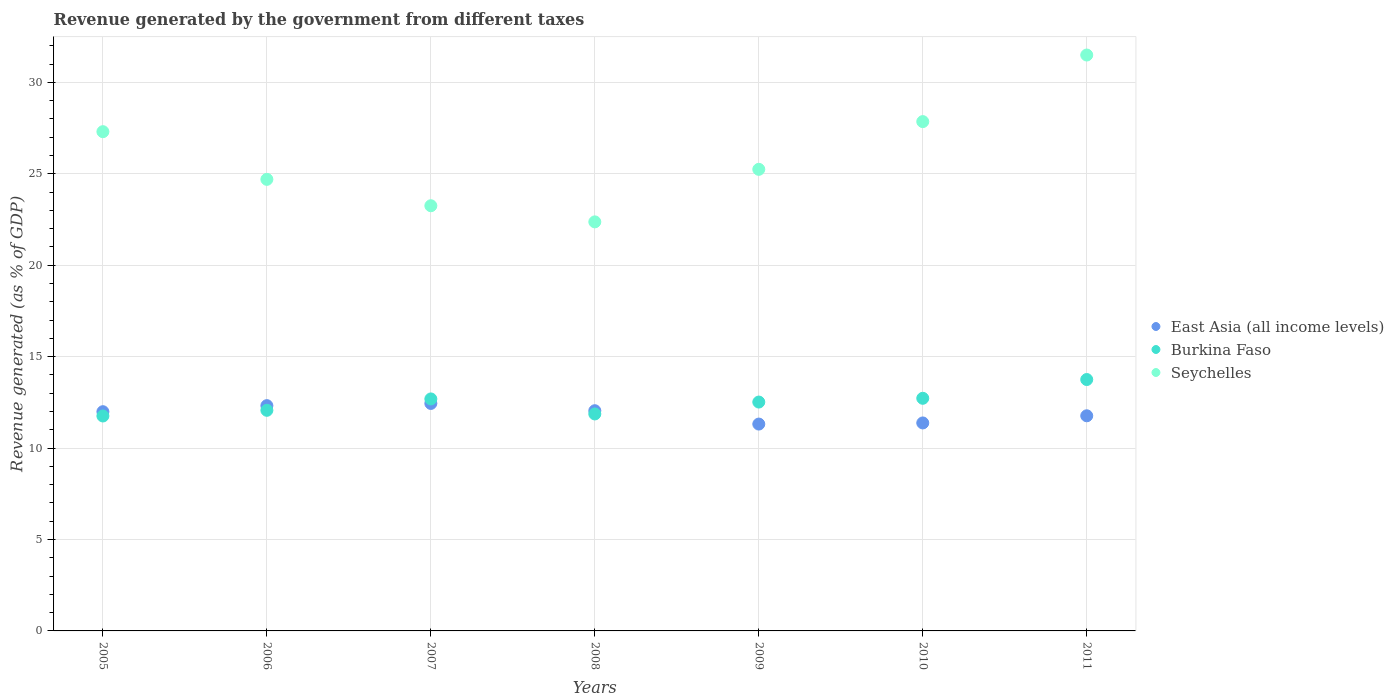Is the number of dotlines equal to the number of legend labels?
Give a very brief answer. Yes. What is the revenue generated by the government in Seychelles in 2006?
Keep it short and to the point. 24.69. Across all years, what is the maximum revenue generated by the government in East Asia (all income levels)?
Provide a succinct answer. 12.44. Across all years, what is the minimum revenue generated by the government in Burkina Faso?
Your answer should be very brief. 11.75. What is the total revenue generated by the government in Seychelles in the graph?
Your response must be concise. 182.19. What is the difference between the revenue generated by the government in Seychelles in 2005 and that in 2011?
Keep it short and to the point. -4.19. What is the difference between the revenue generated by the government in East Asia (all income levels) in 2007 and the revenue generated by the government in Burkina Faso in 2008?
Provide a short and direct response. 0.57. What is the average revenue generated by the government in Burkina Faso per year?
Make the answer very short. 12.48. In the year 2009, what is the difference between the revenue generated by the government in Burkina Faso and revenue generated by the government in East Asia (all income levels)?
Offer a very short reply. 1.2. What is the ratio of the revenue generated by the government in Burkina Faso in 2006 to that in 2009?
Ensure brevity in your answer.  0.96. Is the revenue generated by the government in Seychelles in 2007 less than that in 2008?
Your answer should be very brief. No. Is the difference between the revenue generated by the government in Burkina Faso in 2010 and 2011 greater than the difference between the revenue generated by the government in East Asia (all income levels) in 2010 and 2011?
Make the answer very short. No. What is the difference between the highest and the second highest revenue generated by the government in Burkina Faso?
Give a very brief answer. 1.03. What is the difference between the highest and the lowest revenue generated by the government in East Asia (all income levels)?
Offer a very short reply. 1.13. Is the sum of the revenue generated by the government in East Asia (all income levels) in 2010 and 2011 greater than the maximum revenue generated by the government in Burkina Faso across all years?
Provide a succinct answer. Yes. How many dotlines are there?
Give a very brief answer. 3. What is the difference between two consecutive major ticks on the Y-axis?
Give a very brief answer. 5. How are the legend labels stacked?
Ensure brevity in your answer.  Vertical. What is the title of the graph?
Provide a succinct answer. Revenue generated by the government from different taxes. What is the label or title of the X-axis?
Make the answer very short. Years. What is the label or title of the Y-axis?
Your answer should be compact. Revenue generated (as % of GDP). What is the Revenue generated (as % of GDP) in East Asia (all income levels) in 2005?
Ensure brevity in your answer.  11.99. What is the Revenue generated (as % of GDP) in Burkina Faso in 2005?
Keep it short and to the point. 11.75. What is the Revenue generated (as % of GDP) in Seychelles in 2005?
Keep it short and to the point. 27.3. What is the Revenue generated (as % of GDP) of East Asia (all income levels) in 2006?
Make the answer very short. 12.32. What is the Revenue generated (as % of GDP) of Burkina Faso in 2006?
Ensure brevity in your answer.  12.06. What is the Revenue generated (as % of GDP) in Seychelles in 2006?
Make the answer very short. 24.69. What is the Revenue generated (as % of GDP) of East Asia (all income levels) in 2007?
Give a very brief answer. 12.44. What is the Revenue generated (as % of GDP) in Burkina Faso in 2007?
Keep it short and to the point. 12.69. What is the Revenue generated (as % of GDP) in Seychelles in 2007?
Offer a very short reply. 23.25. What is the Revenue generated (as % of GDP) of East Asia (all income levels) in 2008?
Give a very brief answer. 12.04. What is the Revenue generated (as % of GDP) in Burkina Faso in 2008?
Offer a very short reply. 11.86. What is the Revenue generated (as % of GDP) of Seychelles in 2008?
Offer a terse response. 22.37. What is the Revenue generated (as % of GDP) of East Asia (all income levels) in 2009?
Ensure brevity in your answer.  11.31. What is the Revenue generated (as % of GDP) in Burkina Faso in 2009?
Offer a terse response. 12.52. What is the Revenue generated (as % of GDP) of Seychelles in 2009?
Offer a very short reply. 25.24. What is the Revenue generated (as % of GDP) in East Asia (all income levels) in 2010?
Your response must be concise. 11.37. What is the Revenue generated (as % of GDP) of Burkina Faso in 2010?
Ensure brevity in your answer.  12.72. What is the Revenue generated (as % of GDP) in Seychelles in 2010?
Your answer should be compact. 27.85. What is the Revenue generated (as % of GDP) in East Asia (all income levels) in 2011?
Offer a terse response. 11.76. What is the Revenue generated (as % of GDP) in Burkina Faso in 2011?
Give a very brief answer. 13.75. What is the Revenue generated (as % of GDP) of Seychelles in 2011?
Your answer should be compact. 31.49. Across all years, what is the maximum Revenue generated (as % of GDP) of East Asia (all income levels)?
Offer a terse response. 12.44. Across all years, what is the maximum Revenue generated (as % of GDP) of Burkina Faso?
Provide a succinct answer. 13.75. Across all years, what is the maximum Revenue generated (as % of GDP) in Seychelles?
Ensure brevity in your answer.  31.49. Across all years, what is the minimum Revenue generated (as % of GDP) of East Asia (all income levels)?
Provide a short and direct response. 11.31. Across all years, what is the minimum Revenue generated (as % of GDP) in Burkina Faso?
Your response must be concise. 11.75. Across all years, what is the minimum Revenue generated (as % of GDP) in Seychelles?
Provide a short and direct response. 22.37. What is the total Revenue generated (as % of GDP) in East Asia (all income levels) in the graph?
Ensure brevity in your answer.  83.24. What is the total Revenue generated (as % of GDP) in Burkina Faso in the graph?
Make the answer very short. 87.35. What is the total Revenue generated (as % of GDP) in Seychelles in the graph?
Offer a very short reply. 182.19. What is the difference between the Revenue generated (as % of GDP) in East Asia (all income levels) in 2005 and that in 2006?
Provide a short and direct response. -0.33. What is the difference between the Revenue generated (as % of GDP) in Burkina Faso in 2005 and that in 2006?
Offer a very short reply. -0.31. What is the difference between the Revenue generated (as % of GDP) in Seychelles in 2005 and that in 2006?
Ensure brevity in your answer.  2.61. What is the difference between the Revenue generated (as % of GDP) of East Asia (all income levels) in 2005 and that in 2007?
Make the answer very short. -0.45. What is the difference between the Revenue generated (as % of GDP) in Burkina Faso in 2005 and that in 2007?
Keep it short and to the point. -0.93. What is the difference between the Revenue generated (as % of GDP) in Seychelles in 2005 and that in 2007?
Your answer should be compact. 4.05. What is the difference between the Revenue generated (as % of GDP) of East Asia (all income levels) in 2005 and that in 2008?
Your answer should be compact. -0.05. What is the difference between the Revenue generated (as % of GDP) of Burkina Faso in 2005 and that in 2008?
Your answer should be compact. -0.11. What is the difference between the Revenue generated (as % of GDP) of Seychelles in 2005 and that in 2008?
Your response must be concise. 4.93. What is the difference between the Revenue generated (as % of GDP) in East Asia (all income levels) in 2005 and that in 2009?
Your answer should be compact. 0.68. What is the difference between the Revenue generated (as % of GDP) in Burkina Faso in 2005 and that in 2009?
Give a very brief answer. -0.76. What is the difference between the Revenue generated (as % of GDP) of Seychelles in 2005 and that in 2009?
Keep it short and to the point. 2.06. What is the difference between the Revenue generated (as % of GDP) of East Asia (all income levels) in 2005 and that in 2010?
Offer a very short reply. 0.61. What is the difference between the Revenue generated (as % of GDP) in Burkina Faso in 2005 and that in 2010?
Provide a short and direct response. -0.97. What is the difference between the Revenue generated (as % of GDP) of Seychelles in 2005 and that in 2010?
Keep it short and to the point. -0.55. What is the difference between the Revenue generated (as % of GDP) of East Asia (all income levels) in 2005 and that in 2011?
Your answer should be compact. 0.22. What is the difference between the Revenue generated (as % of GDP) in Burkina Faso in 2005 and that in 2011?
Make the answer very short. -1.99. What is the difference between the Revenue generated (as % of GDP) in Seychelles in 2005 and that in 2011?
Your response must be concise. -4.19. What is the difference between the Revenue generated (as % of GDP) of East Asia (all income levels) in 2006 and that in 2007?
Your response must be concise. -0.12. What is the difference between the Revenue generated (as % of GDP) in Burkina Faso in 2006 and that in 2007?
Provide a short and direct response. -0.62. What is the difference between the Revenue generated (as % of GDP) in Seychelles in 2006 and that in 2007?
Provide a succinct answer. 1.44. What is the difference between the Revenue generated (as % of GDP) in East Asia (all income levels) in 2006 and that in 2008?
Your response must be concise. 0.28. What is the difference between the Revenue generated (as % of GDP) of Burkina Faso in 2006 and that in 2008?
Offer a very short reply. 0.2. What is the difference between the Revenue generated (as % of GDP) of Seychelles in 2006 and that in 2008?
Your answer should be very brief. 2.33. What is the difference between the Revenue generated (as % of GDP) of East Asia (all income levels) in 2006 and that in 2009?
Give a very brief answer. 1.01. What is the difference between the Revenue generated (as % of GDP) of Burkina Faso in 2006 and that in 2009?
Your answer should be compact. -0.45. What is the difference between the Revenue generated (as % of GDP) in Seychelles in 2006 and that in 2009?
Your answer should be very brief. -0.55. What is the difference between the Revenue generated (as % of GDP) in East Asia (all income levels) in 2006 and that in 2010?
Your answer should be compact. 0.95. What is the difference between the Revenue generated (as % of GDP) of Burkina Faso in 2006 and that in 2010?
Make the answer very short. -0.66. What is the difference between the Revenue generated (as % of GDP) of Seychelles in 2006 and that in 2010?
Provide a short and direct response. -3.16. What is the difference between the Revenue generated (as % of GDP) of East Asia (all income levels) in 2006 and that in 2011?
Offer a very short reply. 0.56. What is the difference between the Revenue generated (as % of GDP) in Burkina Faso in 2006 and that in 2011?
Give a very brief answer. -1.68. What is the difference between the Revenue generated (as % of GDP) of Seychelles in 2006 and that in 2011?
Your answer should be compact. -6.8. What is the difference between the Revenue generated (as % of GDP) in East Asia (all income levels) in 2007 and that in 2008?
Give a very brief answer. 0.4. What is the difference between the Revenue generated (as % of GDP) of Burkina Faso in 2007 and that in 2008?
Your answer should be compact. 0.82. What is the difference between the Revenue generated (as % of GDP) in Seychelles in 2007 and that in 2008?
Provide a short and direct response. 0.88. What is the difference between the Revenue generated (as % of GDP) of East Asia (all income levels) in 2007 and that in 2009?
Your response must be concise. 1.13. What is the difference between the Revenue generated (as % of GDP) in Burkina Faso in 2007 and that in 2009?
Your response must be concise. 0.17. What is the difference between the Revenue generated (as % of GDP) of Seychelles in 2007 and that in 2009?
Ensure brevity in your answer.  -1.99. What is the difference between the Revenue generated (as % of GDP) of East Asia (all income levels) in 2007 and that in 2010?
Keep it short and to the point. 1.07. What is the difference between the Revenue generated (as % of GDP) in Burkina Faso in 2007 and that in 2010?
Ensure brevity in your answer.  -0.03. What is the difference between the Revenue generated (as % of GDP) in Seychelles in 2007 and that in 2010?
Make the answer very short. -4.6. What is the difference between the Revenue generated (as % of GDP) in East Asia (all income levels) in 2007 and that in 2011?
Keep it short and to the point. 0.68. What is the difference between the Revenue generated (as % of GDP) in Burkina Faso in 2007 and that in 2011?
Keep it short and to the point. -1.06. What is the difference between the Revenue generated (as % of GDP) of Seychelles in 2007 and that in 2011?
Ensure brevity in your answer.  -8.24. What is the difference between the Revenue generated (as % of GDP) in East Asia (all income levels) in 2008 and that in 2009?
Your response must be concise. 0.73. What is the difference between the Revenue generated (as % of GDP) of Burkina Faso in 2008 and that in 2009?
Keep it short and to the point. -0.65. What is the difference between the Revenue generated (as % of GDP) in Seychelles in 2008 and that in 2009?
Offer a terse response. -2.87. What is the difference between the Revenue generated (as % of GDP) in East Asia (all income levels) in 2008 and that in 2010?
Your response must be concise. 0.67. What is the difference between the Revenue generated (as % of GDP) of Burkina Faso in 2008 and that in 2010?
Your answer should be very brief. -0.86. What is the difference between the Revenue generated (as % of GDP) in Seychelles in 2008 and that in 2010?
Keep it short and to the point. -5.48. What is the difference between the Revenue generated (as % of GDP) of East Asia (all income levels) in 2008 and that in 2011?
Your answer should be very brief. 0.28. What is the difference between the Revenue generated (as % of GDP) of Burkina Faso in 2008 and that in 2011?
Ensure brevity in your answer.  -1.88. What is the difference between the Revenue generated (as % of GDP) of Seychelles in 2008 and that in 2011?
Your response must be concise. -9.12. What is the difference between the Revenue generated (as % of GDP) in East Asia (all income levels) in 2009 and that in 2010?
Give a very brief answer. -0.06. What is the difference between the Revenue generated (as % of GDP) of Burkina Faso in 2009 and that in 2010?
Offer a very short reply. -0.21. What is the difference between the Revenue generated (as % of GDP) in Seychelles in 2009 and that in 2010?
Provide a succinct answer. -2.61. What is the difference between the Revenue generated (as % of GDP) in East Asia (all income levels) in 2009 and that in 2011?
Offer a terse response. -0.45. What is the difference between the Revenue generated (as % of GDP) in Burkina Faso in 2009 and that in 2011?
Your answer should be compact. -1.23. What is the difference between the Revenue generated (as % of GDP) in Seychelles in 2009 and that in 2011?
Ensure brevity in your answer.  -6.25. What is the difference between the Revenue generated (as % of GDP) in East Asia (all income levels) in 2010 and that in 2011?
Your answer should be compact. -0.39. What is the difference between the Revenue generated (as % of GDP) of Burkina Faso in 2010 and that in 2011?
Your response must be concise. -1.03. What is the difference between the Revenue generated (as % of GDP) in Seychelles in 2010 and that in 2011?
Provide a succinct answer. -3.64. What is the difference between the Revenue generated (as % of GDP) in East Asia (all income levels) in 2005 and the Revenue generated (as % of GDP) in Burkina Faso in 2006?
Your response must be concise. -0.08. What is the difference between the Revenue generated (as % of GDP) in East Asia (all income levels) in 2005 and the Revenue generated (as % of GDP) in Seychelles in 2006?
Ensure brevity in your answer.  -12.7. What is the difference between the Revenue generated (as % of GDP) of Burkina Faso in 2005 and the Revenue generated (as % of GDP) of Seychelles in 2006?
Offer a terse response. -12.94. What is the difference between the Revenue generated (as % of GDP) in East Asia (all income levels) in 2005 and the Revenue generated (as % of GDP) in Burkina Faso in 2007?
Ensure brevity in your answer.  -0.7. What is the difference between the Revenue generated (as % of GDP) in East Asia (all income levels) in 2005 and the Revenue generated (as % of GDP) in Seychelles in 2007?
Offer a terse response. -11.26. What is the difference between the Revenue generated (as % of GDP) in Burkina Faso in 2005 and the Revenue generated (as % of GDP) in Seychelles in 2007?
Provide a succinct answer. -11.5. What is the difference between the Revenue generated (as % of GDP) in East Asia (all income levels) in 2005 and the Revenue generated (as % of GDP) in Burkina Faso in 2008?
Your answer should be very brief. 0.12. What is the difference between the Revenue generated (as % of GDP) of East Asia (all income levels) in 2005 and the Revenue generated (as % of GDP) of Seychelles in 2008?
Your answer should be compact. -10.38. What is the difference between the Revenue generated (as % of GDP) in Burkina Faso in 2005 and the Revenue generated (as % of GDP) in Seychelles in 2008?
Your answer should be compact. -10.61. What is the difference between the Revenue generated (as % of GDP) in East Asia (all income levels) in 2005 and the Revenue generated (as % of GDP) in Burkina Faso in 2009?
Make the answer very short. -0.53. What is the difference between the Revenue generated (as % of GDP) of East Asia (all income levels) in 2005 and the Revenue generated (as % of GDP) of Seychelles in 2009?
Offer a terse response. -13.25. What is the difference between the Revenue generated (as % of GDP) of Burkina Faso in 2005 and the Revenue generated (as % of GDP) of Seychelles in 2009?
Offer a very short reply. -13.49. What is the difference between the Revenue generated (as % of GDP) of East Asia (all income levels) in 2005 and the Revenue generated (as % of GDP) of Burkina Faso in 2010?
Give a very brief answer. -0.73. What is the difference between the Revenue generated (as % of GDP) of East Asia (all income levels) in 2005 and the Revenue generated (as % of GDP) of Seychelles in 2010?
Offer a very short reply. -15.86. What is the difference between the Revenue generated (as % of GDP) in Burkina Faso in 2005 and the Revenue generated (as % of GDP) in Seychelles in 2010?
Ensure brevity in your answer.  -16.1. What is the difference between the Revenue generated (as % of GDP) in East Asia (all income levels) in 2005 and the Revenue generated (as % of GDP) in Burkina Faso in 2011?
Offer a terse response. -1.76. What is the difference between the Revenue generated (as % of GDP) of East Asia (all income levels) in 2005 and the Revenue generated (as % of GDP) of Seychelles in 2011?
Provide a succinct answer. -19.5. What is the difference between the Revenue generated (as % of GDP) of Burkina Faso in 2005 and the Revenue generated (as % of GDP) of Seychelles in 2011?
Provide a succinct answer. -19.74. What is the difference between the Revenue generated (as % of GDP) of East Asia (all income levels) in 2006 and the Revenue generated (as % of GDP) of Burkina Faso in 2007?
Offer a very short reply. -0.37. What is the difference between the Revenue generated (as % of GDP) of East Asia (all income levels) in 2006 and the Revenue generated (as % of GDP) of Seychelles in 2007?
Offer a very short reply. -10.93. What is the difference between the Revenue generated (as % of GDP) in Burkina Faso in 2006 and the Revenue generated (as % of GDP) in Seychelles in 2007?
Make the answer very short. -11.19. What is the difference between the Revenue generated (as % of GDP) of East Asia (all income levels) in 2006 and the Revenue generated (as % of GDP) of Burkina Faso in 2008?
Your answer should be compact. 0.45. What is the difference between the Revenue generated (as % of GDP) in East Asia (all income levels) in 2006 and the Revenue generated (as % of GDP) in Seychelles in 2008?
Your answer should be compact. -10.05. What is the difference between the Revenue generated (as % of GDP) of Burkina Faso in 2006 and the Revenue generated (as % of GDP) of Seychelles in 2008?
Your answer should be very brief. -10.3. What is the difference between the Revenue generated (as % of GDP) in East Asia (all income levels) in 2006 and the Revenue generated (as % of GDP) in Burkina Faso in 2009?
Offer a terse response. -0.2. What is the difference between the Revenue generated (as % of GDP) of East Asia (all income levels) in 2006 and the Revenue generated (as % of GDP) of Seychelles in 2009?
Ensure brevity in your answer.  -12.92. What is the difference between the Revenue generated (as % of GDP) in Burkina Faso in 2006 and the Revenue generated (as % of GDP) in Seychelles in 2009?
Keep it short and to the point. -13.18. What is the difference between the Revenue generated (as % of GDP) of East Asia (all income levels) in 2006 and the Revenue generated (as % of GDP) of Burkina Faso in 2010?
Your answer should be very brief. -0.4. What is the difference between the Revenue generated (as % of GDP) in East Asia (all income levels) in 2006 and the Revenue generated (as % of GDP) in Seychelles in 2010?
Your answer should be very brief. -15.53. What is the difference between the Revenue generated (as % of GDP) of Burkina Faso in 2006 and the Revenue generated (as % of GDP) of Seychelles in 2010?
Your answer should be very brief. -15.79. What is the difference between the Revenue generated (as % of GDP) of East Asia (all income levels) in 2006 and the Revenue generated (as % of GDP) of Burkina Faso in 2011?
Ensure brevity in your answer.  -1.43. What is the difference between the Revenue generated (as % of GDP) in East Asia (all income levels) in 2006 and the Revenue generated (as % of GDP) in Seychelles in 2011?
Your response must be concise. -19.17. What is the difference between the Revenue generated (as % of GDP) of Burkina Faso in 2006 and the Revenue generated (as % of GDP) of Seychelles in 2011?
Give a very brief answer. -19.43. What is the difference between the Revenue generated (as % of GDP) of East Asia (all income levels) in 2007 and the Revenue generated (as % of GDP) of Burkina Faso in 2008?
Your response must be concise. 0.57. What is the difference between the Revenue generated (as % of GDP) in East Asia (all income levels) in 2007 and the Revenue generated (as % of GDP) in Seychelles in 2008?
Provide a succinct answer. -9.93. What is the difference between the Revenue generated (as % of GDP) in Burkina Faso in 2007 and the Revenue generated (as % of GDP) in Seychelles in 2008?
Offer a terse response. -9.68. What is the difference between the Revenue generated (as % of GDP) of East Asia (all income levels) in 2007 and the Revenue generated (as % of GDP) of Burkina Faso in 2009?
Offer a very short reply. -0.08. What is the difference between the Revenue generated (as % of GDP) of East Asia (all income levels) in 2007 and the Revenue generated (as % of GDP) of Seychelles in 2009?
Keep it short and to the point. -12.8. What is the difference between the Revenue generated (as % of GDP) of Burkina Faso in 2007 and the Revenue generated (as % of GDP) of Seychelles in 2009?
Ensure brevity in your answer.  -12.56. What is the difference between the Revenue generated (as % of GDP) in East Asia (all income levels) in 2007 and the Revenue generated (as % of GDP) in Burkina Faso in 2010?
Your answer should be very brief. -0.28. What is the difference between the Revenue generated (as % of GDP) of East Asia (all income levels) in 2007 and the Revenue generated (as % of GDP) of Seychelles in 2010?
Your answer should be compact. -15.41. What is the difference between the Revenue generated (as % of GDP) of Burkina Faso in 2007 and the Revenue generated (as % of GDP) of Seychelles in 2010?
Your response must be concise. -15.16. What is the difference between the Revenue generated (as % of GDP) of East Asia (all income levels) in 2007 and the Revenue generated (as % of GDP) of Burkina Faso in 2011?
Offer a terse response. -1.31. What is the difference between the Revenue generated (as % of GDP) of East Asia (all income levels) in 2007 and the Revenue generated (as % of GDP) of Seychelles in 2011?
Offer a terse response. -19.05. What is the difference between the Revenue generated (as % of GDP) in Burkina Faso in 2007 and the Revenue generated (as % of GDP) in Seychelles in 2011?
Make the answer very short. -18.81. What is the difference between the Revenue generated (as % of GDP) in East Asia (all income levels) in 2008 and the Revenue generated (as % of GDP) in Burkina Faso in 2009?
Provide a succinct answer. -0.47. What is the difference between the Revenue generated (as % of GDP) in East Asia (all income levels) in 2008 and the Revenue generated (as % of GDP) in Seychelles in 2009?
Provide a short and direct response. -13.2. What is the difference between the Revenue generated (as % of GDP) in Burkina Faso in 2008 and the Revenue generated (as % of GDP) in Seychelles in 2009?
Give a very brief answer. -13.38. What is the difference between the Revenue generated (as % of GDP) of East Asia (all income levels) in 2008 and the Revenue generated (as % of GDP) of Burkina Faso in 2010?
Your answer should be compact. -0.68. What is the difference between the Revenue generated (as % of GDP) in East Asia (all income levels) in 2008 and the Revenue generated (as % of GDP) in Seychelles in 2010?
Provide a short and direct response. -15.81. What is the difference between the Revenue generated (as % of GDP) of Burkina Faso in 2008 and the Revenue generated (as % of GDP) of Seychelles in 2010?
Keep it short and to the point. -15.99. What is the difference between the Revenue generated (as % of GDP) of East Asia (all income levels) in 2008 and the Revenue generated (as % of GDP) of Burkina Faso in 2011?
Offer a terse response. -1.71. What is the difference between the Revenue generated (as % of GDP) of East Asia (all income levels) in 2008 and the Revenue generated (as % of GDP) of Seychelles in 2011?
Provide a succinct answer. -19.45. What is the difference between the Revenue generated (as % of GDP) of Burkina Faso in 2008 and the Revenue generated (as % of GDP) of Seychelles in 2011?
Your response must be concise. -19.63. What is the difference between the Revenue generated (as % of GDP) of East Asia (all income levels) in 2009 and the Revenue generated (as % of GDP) of Burkina Faso in 2010?
Provide a succinct answer. -1.41. What is the difference between the Revenue generated (as % of GDP) of East Asia (all income levels) in 2009 and the Revenue generated (as % of GDP) of Seychelles in 2010?
Provide a short and direct response. -16.54. What is the difference between the Revenue generated (as % of GDP) in Burkina Faso in 2009 and the Revenue generated (as % of GDP) in Seychelles in 2010?
Keep it short and to the point. -15.34. What is the difference between the Revenue generated (as % of GDP) of East Asia (all income levels) in 2009 and the Revenue generated (as % of GDP) of Burkina Faso in 2011?
Your answer should be compact. -2.44. What is the difference between the Revenue generated (as % of GDP) in East Asia (all income levels) in 2009 and the Revenue generated (as % of GDP) in Seychelles in 2011?
Ensure brevity in your answer.  -20.18. What is the difference between the Revenue generated (as % of GDP) of Burkina Faso in 2009 and the Revenue generated (as % of GDP) of Seychelles in 2011?
Your answer should be very brief. -18.98. What is the difference between the Revenue generated (as % of GDP) in East Asia (all income levels) in 2010 and the Revenue generated (as % of GDP) in Burkina Faso in 2011?
Offer a very short reply. -2.37. What is the difference between the Revenue generated (as % of GDP) of East Asia (all income levels) in 2010 and the Revenue generated (as % of GDP) of Seychelles in 2011?
Your answer should be compact. -20.12. What is the difference between the Revenue generated (as % of GDP) in Burkina Faso in 2010 and the Revenue generated (as % of GDP) in Seychelles in 2011?
Make the answer very short. -18.77. What is the average Revenue generated (as % of GDP) of East Asia (all income levels) per year?
Make the answer very short. 11.89. What is the average Revenue generated (as % of GDP) of Burkina Faso per year?
Make the answer very short. 12.48. What is the average Revenue generated (as % of GDP) of Seychelles per year?
Make the answer very short. 26.03. In the year 2005, what is the difference between the Revenue generated (as % of GDP) of East Asia (all income levels) and Revenue generated (as % of GDP) of Burkina Faso?
Offer a terse response. 0.24. In the year 2005, what is the difference between the Revenue generated (as % of GDP) in East Asia (all income levels) and Revenue generated (as % of GDP) in Seychelles?
Provide a succinct answer. -15.31. In the year 2005, what is the difference between the Revenue generated (as % of GDP) in Burkina Faso and Revenue generated (as % of GDP) in Seychelles?
Make the answer very short. -15.55. In the year 2006, what is the difference between the Revenue generated (as % of GDP) of East Asia (all income levels) and Revenue generated (as % of GDP) of Burkina Faso?
Ensure brevity in your answer.  0.26. In the year 2006, what is the difference between the Revenue generated (as % of GDP) in East Asia (all income levels) and Revenue generated (as % of GDP) in Seychelles?
Provide a succinct answer. -12.37. In the year 2006, what is the difference between the Revenue generated (as % of GDP) of Burkina Faso and Revenue generated (as % of GDP) of Seychelles?
Make the answer very short. -12.63. In the year 2007, what is the difference between the Revenue generated (as % of GDP) in East Asia (all income levels) and Revenue generated (as % of GDP) in Burkina Faso?
Your answer should be compact. -0.25. In the year 2007, what is the difference between the Revenue generated (as % of GDP) of East Asia (all income levels) and Revenue generated (as % of GDP) of Seychelles?
Your answer should be very brief. -10.81. In the year 2007, what is the difference between the Revenue generated (as % of GDP) of Burkina Faso and Revenue generated (as % of GDP) of Seychelles?
Your answer should be very brief. -10.56. In the year 2008, what is the difference between the Revenue generated (as % of GDP) in East Asia (all income levels) and Revenue generated (as % of GDP) in Burkina Faso?
Keep it short and to the point. 0.18. In the year 2008, what is the difference between the Revenue generated (as % of GDP) of East Asia (all income levels) and Revenue generated (as % of GDP) of Seychelles?
Your answer should be compact. -10.33. In the year 2008, what is the difference between the Revenue generated (as % of GDP) in Burkina Faso and Revenue generated (as % of GDP) in Seychelles?
Offer a very short reply. -10.5. In the year 2009, what is the difference between the Revenue generated (as % of GDP) in East Asia (all income levels) and Revenue generated (as % of GDP) in Burkina Faso?
Keep it short and to the point. -1.2. In the year 2009, what is the difference between the Revenue generated (as % of GDP) of East Asia (all income levels) and Revenue generated (as % of GDP) of Seychelles?
Give a very brief answer. -13.93. In the year 2009, what is the difference between the Revenue generated (as % of GDP) in Burkina Faso and Revenue generated (as % of GDP) in Seychelles?
Offer a very short reply. -12.73. In the year 2010, what is the difference between the Revenue generated (as % of GDP) of East Asia (all income levels) and Revenue generated (as % of GDP) of Burkina Faso?
Give a very brief answer. -1.35. In the year 2010, what is the difference between the Revenue generated (as % of GDP) of East Asia (all income levels) and Revenue generated (as % of GDP) of Seychelles?
Give a very brief answer. -16.48. In the year 2010, what is the difference between the Revenue generated (as % of GDP) in Burkina Faso and Revenue generated (as % of GDP) in Seychelles?
Your answer should be compact. -15.13. In the year 2011, what is the difference between the Revenue generated (as % of GDP) in East Asia (all income levels) and Revenue generated (as % of GDP) in Burkina Faso?
Offer a terse response. -1.98. In the year 2011, what is the difference between the Revenue generated (as % of GDP) in East Asia (all income levels) and Revenue generated (as % of GDP) in Seychelles?
Your answer should be very brief. -19.73. In the year 2011, what is the difference between the Revenue generated (as % of GDP) in Burkina Faso and Revenue generated (as % of GDP) in Seychelles?
Keep it short and to the point. -17.74. What is the ratio of the Revenue generated (as % of GDP) of East Asia (all income levels) in 2005 to that in 2006?
Make the answer very short. 0.97. What is the ratio of the Revenue generated (as % of GDP) of Burkina Faso in 2005 to that in 2006?
Make the answer very short. 0.97. What is the ratio of the Revenue generated (as % of GDP) in Seychelles in 2005 to that in 2006?
Offer a terse response. 1.11. What is the ratio of the Revenue generated (as % of GDP) of East Asia (all income levels) in 2005 to that in 2007?
Provide a short and direct response. 0.96. What is the ratio of the Revenue generated (as % of GDP) of Burkina Faso in 2005 to that in 2007?
Provide a short and direct response. 0.93. What is the ratio of the Revenue generated (as % of GDP) of Seychelles in 2005 to that in 2007?
Make the answer very short. 1.17. What is the ratio of the Revenue generated (as % of GDP) in Burkina Faso in 2005 to that in 2008?
Give a very brief answer. 0.99. What is the ratio of the Revenue generated (as % of GDP) of Seychelles in 2005 to that in 2008?
Your answer should be very brief. 1.22. What is the ratio of the Revenue generated (as % of GDP) of East Asia (all income levels) in 2005 to that in 2009?
Offer a very short reply. 1.06. What is the ratio of the Revenue generated (as % of GDP) of Burkina Faso in 2005 to that in 2009?
Offer a terse response. 0.94. What is the ratio of the Revenue generated (as % of GDP) in Seychelles in 2005 to that in 2009?
Offer a terse response. 1.08. What is the ratio of the Revenue generated (as % of GDP) in East Asia (all income levels) in 2005 to that in 2010?
Provide a succinct answer. 1.05. What is the ratio of the Revenue generated (as % of GDP) of Burkina Faso in 2005 to that in 2010?
Give a very brief answer. 0.92. What is the ratio of the Revenue generated (as % of GDP) of Seychelles in 2005 to that in 2010?
Give a very brief answer. 0.98. What is the ratio of the Revenue generated (as % of GDP) of Burkina Faso in 2005 to that in 2011?
Offer a very short reply. 0.85. What is the ratio of the Revenue generated (as % of GDP) in Seychelles in 2005 to that in 2011?
Provide a short and direct response. 0.87. What is the ratio of the Revenue generated (as % of GDP) of East Asia (all income levels) in 2006 to that in 2007?
Your response must be concise. 0.99. What is the ratio of the Revenue generated (as % of GDP) in Burkina Faso in 2006 to that in 2007?
Ensure brevity in your answer.  0.95. What is the ratio of the Revenue generated (as % of GDP) in Seychelles in 2006 to that in 2007?
Your answer should be compact. 1.06. What is the ratio of the Revenue generated (as % of GDP) of East Asia (all income levels) in 2006 to that in 2008?
Give a very brief answer. 1.02. What is the ratio of the Revenue generated (as % of GDP) in Burkina Faso in 2006 to that in 2008?
Your response must be concise. 1.02. What is the ratio of the Revenue generated (as % of GDP) in Seychelles in 2006 to that in 2008?
Offer a very short reply. 1.1. What is the ratio of the Revenue generated (as % of GDP) of East Asia (all income levels) in 2006 to that in 2009?
Provide a succinct answer. 1.09. What is the ratio of the Revenue generated (as % of GDP) in Burkina Faso in 2006 to that in 2009?
Your response must be concise. 0.96. What is the ratio of the Revenue generated (as % of GDP) in Seychelles in 2006 to that in 2009?
Give a very brief answer. 0.98. What is the ratio of the Revenue generated (as % of GDP) in East Asia (all income levels) in 2006 to that in 2010?
Your response must be concise. 1.08. What is the ratio of the Revenue generated (as % of GDP) of Burkina Faso in 2006 to that in 2010?
Your response must be concise. 0.95. What is the ratio of the Revenue generated (as % of GDP) in Seychelles in 2006 to that in 2010?
Make the answer very short. 0.89. What is the ratio of the Revenue generated (as % of GDP) of East Asia (all income levels) in 2006 to that in 2011?
Ensure brevity in your answer.  1.05. What is the ratio of the Revenue generated (as % of GDP) of Burkina Faso in 2006 to that in 2011?
Provide a succinct answer. 0.88. What is the ratio of the Revenue generated (as % of GDP) in Seychelles in 2006 to that in 2011?
Make the answer very short. 0.78. What is the ratio of the Revenue generated (as % of GDP) of East Asia (all income levels) in 2007 to that in 2008?
Keep it short and to the point. 1.03. What is the ratio of the Revenue generated (as % of GDP) of Burkina Faso in 2007 to that in 2008?
Your answer should be compact. 1.07. What is the ratio of the Revenue generated (as % of GDP) in Seychelles in 2007 to that in 2008?
Your answer should be compact. 1.04. What is the ratio of the Revenue generated (as % of GDP) in East Asia (all income levels) in 2007 to that in 2009?
Offer a terse response. 1.1. What is the ratio of the Revenue generated (as % of GDP) of Burkina Faso in 2007 to that in 2009?
Offer a terse response. 1.01. What is the ratio of the Revenue generated (as % of GDP) in Seychelles in 2007 to that in 2009?
Keep it short and to the point. 0.92. What is the ratio of the Revenue generated (as % of GDP) in East Asia (all income levels) in 2007 to that in 2010?
Your answer should be compact. 1.09. What is the ratio of the Revenue generated (as % of GDP) in Burkina Faso in 2007 to that in 2010?
Your answer should be compact. 1. What is the ratio of the Revenue generated (as % of GDP) of Seychelles in 2007 to that in 2010?
Make the answer very short. 0.83. What is the ratio of the Revenue generated (as % of GDP) of East Asia (all income levels) in 2007 to that in 2011?
Provide a succinct answer. 1.06. What is the ratio of the Revenue generated (as % of GDP) in Burkina Faso in 2007 to that in 2011?
Offer a very short reply. 0.92. What is the ratio of the Revenue generated (as % of GDP) in Seychelles in 2007 to that in 2011?
Make the answer very short. 0.74. What is the ratio of the Revenue generated (as % of GDP) in East Asia (all income levels) in 2008 to that in 2009?
Offer a terse response. 1.06. What is the ratio of the Revenue generated (as % of GDP) in Burkina Faso in 2008 to that in 2009?
Your answer should be compact. 0.95. What is the ratio of the Revenue generated (as % of GDP) in Seychelles in 2008 to that in 2009?
Keep it short and to the point. 0.89. What is the ratio of the Revenue generated (as % of GDP) in East Asia (all income levels) in 2008 to that in 2010?
Provide a succinct answer. 1.06. What is the ratio of the Revenue generated (as % of GDP) of Burkina Faso in 2008 to that in 2010?
Your response must be concise. 0.93. What is the ratio of the Revenue generated (as % of GDP) in Seychelles in 2008 to that in 2010?
Offer a very short reply. 0.8. What is the ratio of the Revenue generated (as % of GDP) in East Asia (all income levels) in 2008 to that in 2011?
Keep it short and to the point. 1.02. What is the ratio of the Revenue generated (as % of GDP) of Burkina Faso in 2008 to that in 2011?
Provide a succinct answer. 0.86. What is the ratio of the Revenue generated (as % of GDP) of Seychelles in 2008 to that in 2011?
Offer a terse response. 0.71. What is the ratio of the Revenue generated (as % of GDP) in Burkina Faso in 2009 to that in 2010?
Ensure brevity in your answer.  0.98. What is the ratio of the Revenue generated (as % of GDP) in Seychelles in 2009 to that in 2010?
Your answer should be very brief. 0.91. What is the ratio of the Revenue generated (as % of GDP) of East Asia (all income levels) in 2009 to that in 2011?
Ensure brevity in your answer.  0.96. What is the ratio of the Revenue generated (as % of GDP) in Burkina Faso in 2009 to that in 2011?
Provide a succinct answer. 0.91. What is the ratio of the Revenue generated (as % of GDP) of Seychelles in 2009 to that in 2011?
Give a very brief answer. 0.8. What is the ratio of the Revenue generated (as % of GDP) in East Asia (all income levels) in 2010 to that in 2011?
Your answer should be very brief. 0.97. What is the ratio of the Revenue generated (as % of GDP) of Burkina Faso in 2010 to that in 2011?
Give a very brief answer. 0.93. What is the ratio of the Revenue generated (as % of GDP) in Seychelles in 2010 to that in 2011?
Keep it short and to the point. 0.88. What is the difference between the highest and the second highest Revenue generated (as % of GDP) in East Asia (all income levels)?
Offer a very short reply. 0.12. What is the difference between the highest and the second highest Revenue generated (as % of GDP) of Burkina Faso?
Provide a short and direct response. 1.03. What is the difference between the highest and the second highest Revenue generated (as % of GDP) in Seychelles?
Offer a very short reply. 3.64. What is the difference between the highest and the lowest Revenue generated (as % of GDP) of East Asia (all income levels)?
Make the answer very short. 1.13. What is the difference between the highest and the lowest Revenue generated (as % of GDP) in Burkina Faso?
Offer a very short reply. 1.99. What is the difference between the highest and the lowest Revenue generated (as % of GDP) in Seychelles?
Provide a succinct answer. 9.12. 